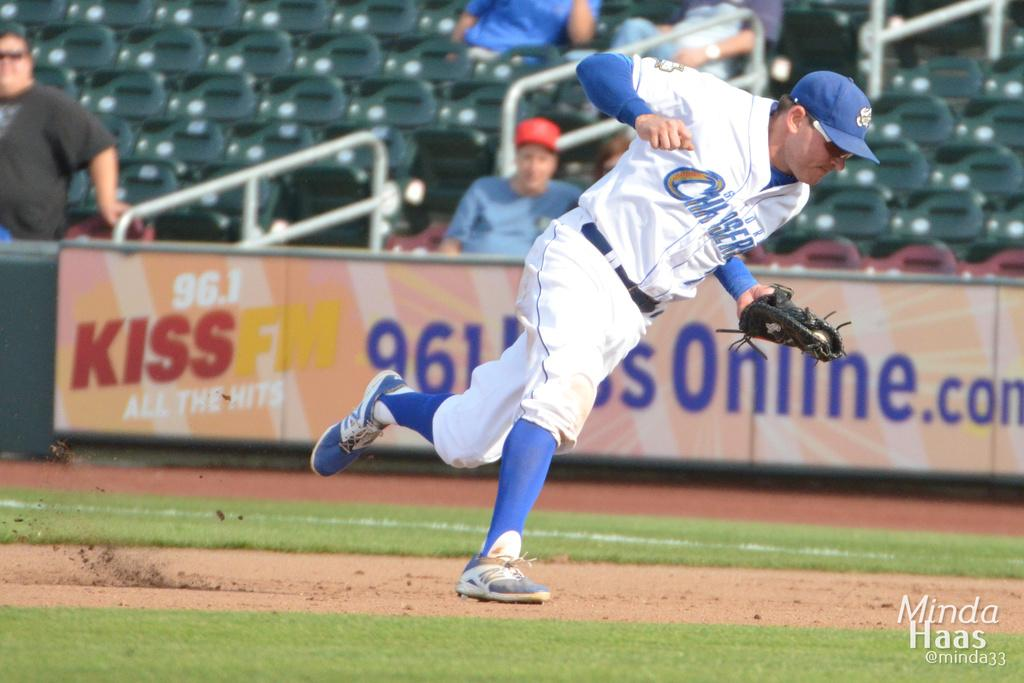<image>
Describe the image concisely. A baseball player infront of a Kiss FM banner 